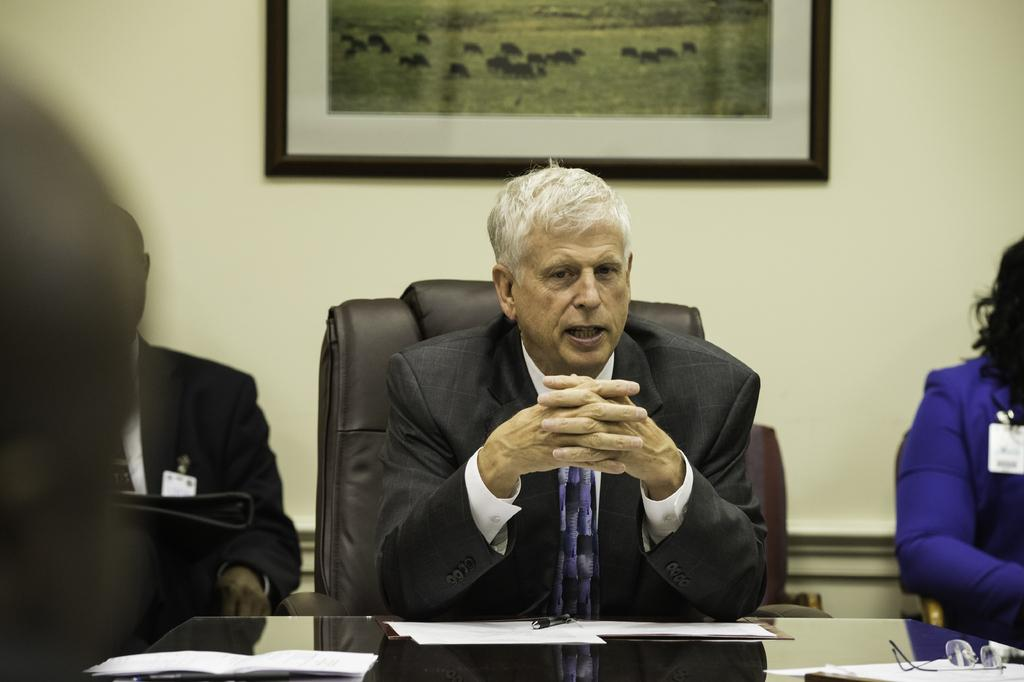What is the man doing in the image? The man is sitting in a chair in the image. Where is the man located in the image? The man is at a table in the image. What is the man doing at the table? The man is speaking with people around him in the image. What type of quiet apparatus is the man using to communicate with the people around him? There is no apparatus present in the image, and the man is speaking verbally with the people around him. 